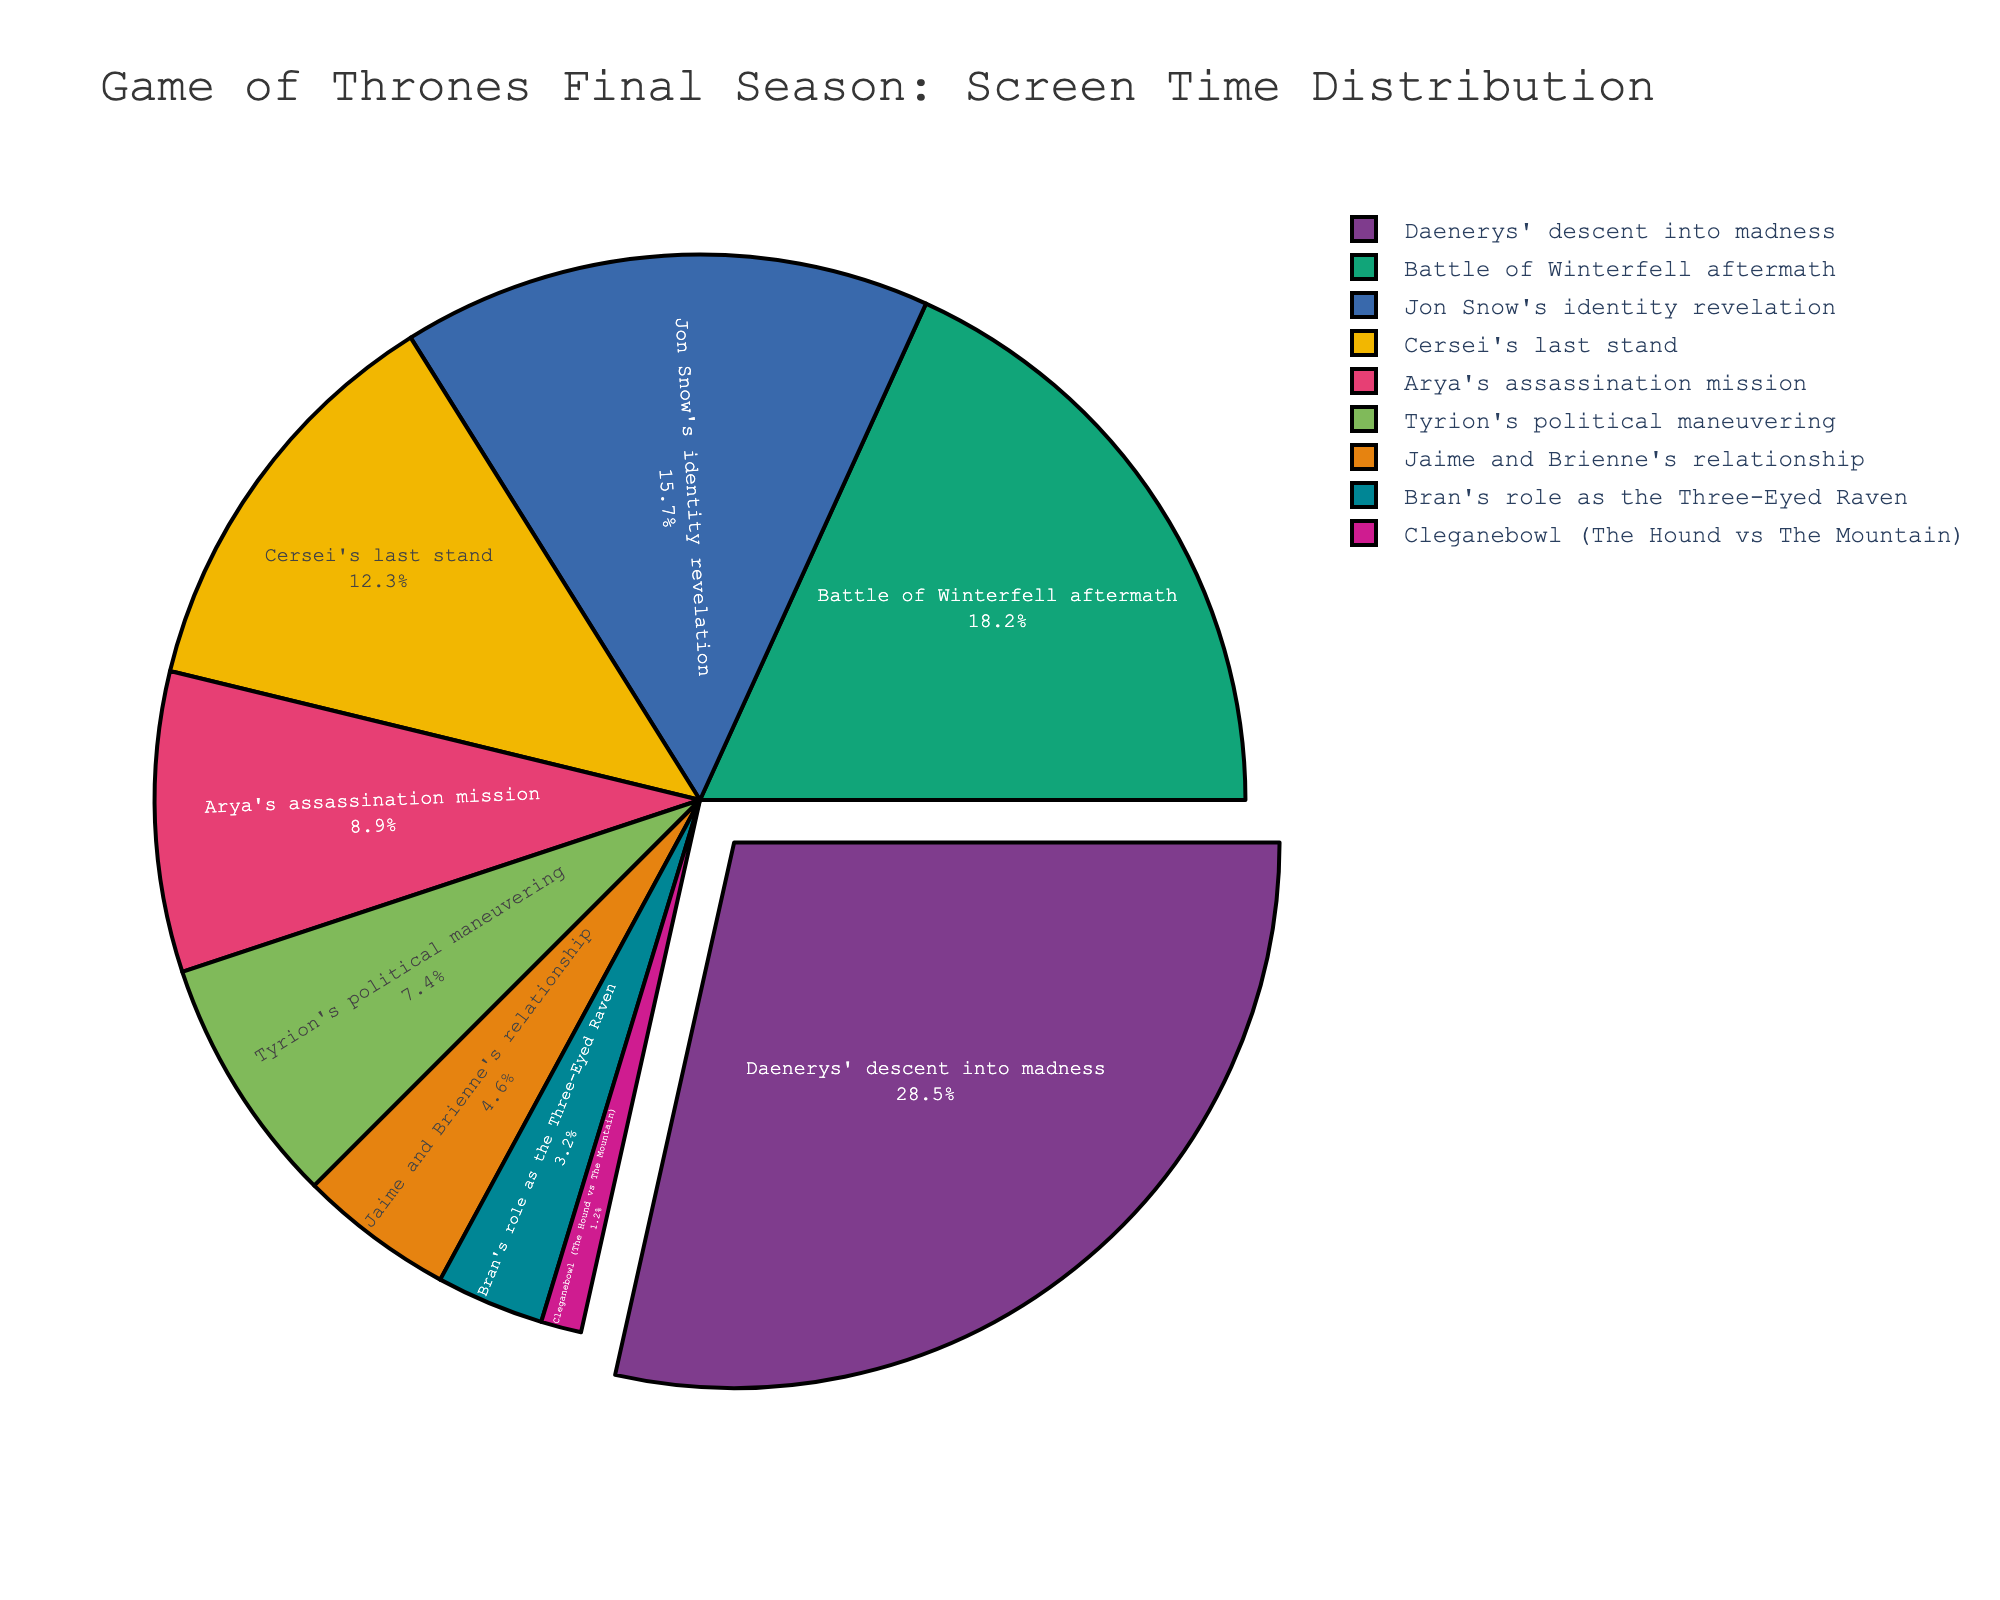Which plotline receives the most screen time in the final season? By examining the pie chart, we can identify that the plotline with the largest segment represents Daenerys' descent into madness, accounting for 28.5% of the screen time.
Answer: Daenerys' descent into madness Which plotline has the least screen time? Looking at the smallest segment of the pie chart, we see that Cleganebowl (The Hound vs The Mountain) takes up the smallest portion at 1.2%.
Answer: Cleganebowl (The Hound vs The Mountain) How does the screen time of Jon Snow's identity revelation compare to Arya's assassination mission? Jon Snow's identity revelation accounts for 15.7% of screen time, while Arya's assassination mission takes 8.9%. Thus, Jon Snow's plotline has more screen time.
Answer: Jon Snow's identity revelation has more screen time What is the combined screen time percentage for Cersei's last stand and Tyrion's political maneuvering? Adding the screen time percentages for Cersei's last stand (12.3%) and Tyrion's political maneuvering (7.4%) gives us 12.3 + 7.4 = 19.7%.
Answer: 19.7% Is Bran's role as the Three-Eyed Raven greater or less than Jaime and Brienne's relationship in screen time? By comparing the two percentages, Bran's role as the Three-Eyed Raven is 3.2%, and Jaime and Brienne's relationship is 4.6%. Therefore, Bran's role has less screen time.
Answer: Less What is the total screen time percentage for the three least prominent plotlines? The three least prominent plotlines are Cleganebowl (1.2%), Bran's role as the Three-Eyed Raven (3.2%), and Jaime and Brienne's relationship (4.6%). Adding these together gives 1.2 + 3.2 + 4.6 = 9.0%.
Answer: 9.0% How much more screen time does Daenerys' descent into madness have compared to the Battle of Winterfell aftermath? Daenerys' descent into madness occupies 28.5%, while the Battle of Winterfell aftermath has 18.2%. The difference is 28.5 - 18.2 = 10.3%.
Answer: 10.3% Rank the plotlines by their screen time percentages from highest to lowest. By examining the segments, the ranking order from highest to lowest is: 
1. Daenerys' descent into madness (28.5%)
2. Battle of Winterfell aftermath (18.2%)
3. Jon Snow's identity revelation (15.7%)
4. Cersei's last stand (12.3%)
5. Arya's assassination mission (8.9%)
6. Tyrion's political maneuvering (7.4%)
7. Jaime and Brienne's relationship (4.6%)
8. Bran's role as the Three-Eyed Raven (3.2%)
9. Cleganebowl (1.2%)
Answer: Daenerys' descent into madness > Battle of Winterfell aftermath > Jon Snow's identity revelation > Cersei's last stand > Arya's assassination mission > Tyrion's political maneuvering > Jaime and Brienne's relationship > Bran's role as the Three-Eyed Raven > Cleganebowl 